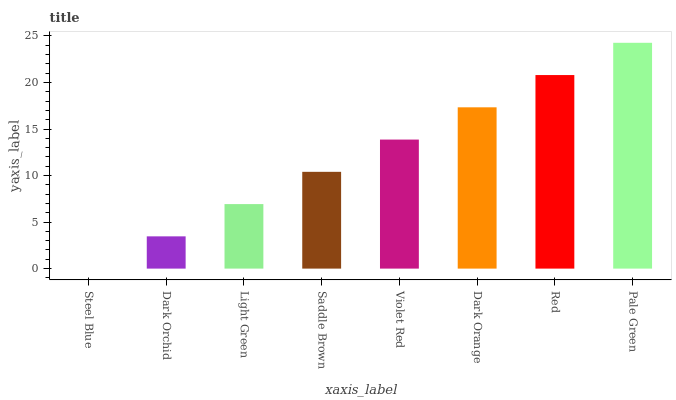Is Steel Blue the minimum?
Answer yes or no. Yes. Is Pale Green the maximum?
Answer yes or no. Yes. Is Dark Orchid the minimum?
Answer yes or no. No. Is Dark Orchid the maximum?
Answer yes or no. No. Is Dark Orchid greater than Steel Blue?
Answer yes or no. Yes. Is Steel Blue less than Dark Orchid?
Answer yes or no. Yes. Is Steel Blue greater than Dark Orchid?
Answer yes or no. No. Is Dark Orchid less than Steel Blue?
Answer yes or no. No. Is Violet Red the high median?
Answer yes or no. Yes. Is Saddle Brown the low median?
Answer yes or no. Yes. Is Dark Orange the high median?
Answer yes or no. No. Is Violet Red the low median?
Answer yes or no. No. 